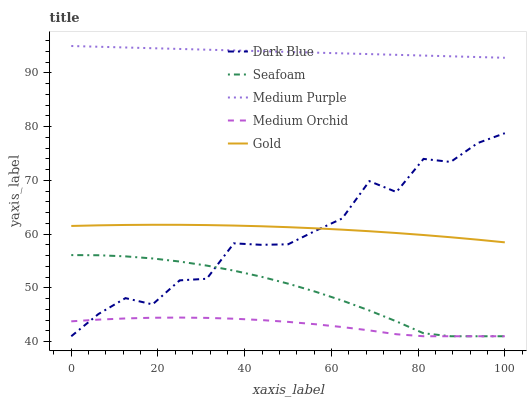Does Dark Blue have the minimum area under the curve?
Answer yes or no. No. Does Dark Blue have the maximum area under the curve?
Answer yes or no. No. Is Medium Orchid the smoothest?
Answer yes or no. No. Is Medium Orchid the roughest?
Answer yes or no. No. Does Gold have the lowest value?
Answer yes or no. No. Does Dark Blue have the highest value?
Answer yes or no. No. Is Medium Orchid less than Medium Purple?
Answer yes or no. Yes. Is Medium Purple greater than Gold?
Answer yes or no. Yes. Does Medium Orchid intersect Medium Purple?
Answer yes or no. No. 